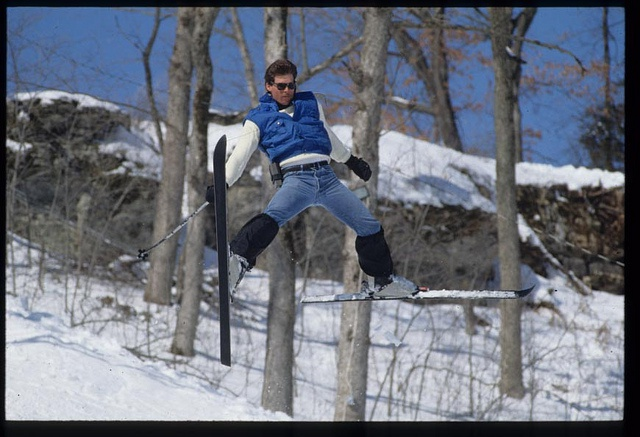Describe the objects in this image and their specific colors. I can see people in black, navy, and gray tones and skis in black, gray, darkgray, and lightgray tones in this image. 